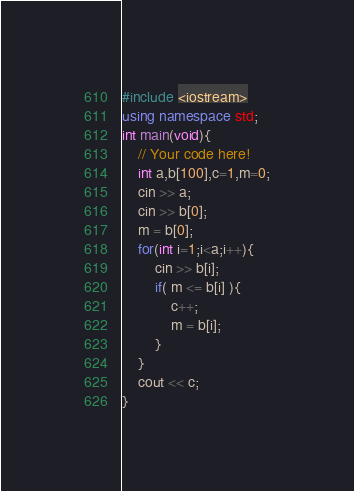Convert code to text. <code><loc_0><loc_0><loc_500><loc_500><_C++_>#include <iostream>
using namespace std;
int main(void){
    // Your code here!
    int a,b[100],c=1,m=0;
    cin >> a;
    cin >> b[0];
    m = b[0];
    for(int i=1;i<a;i++){
        cin >> b[i];
        if( m <= b[i] ){
            c++;
            m = b[i];
        }
    }
    cout << c;
}
</code> 